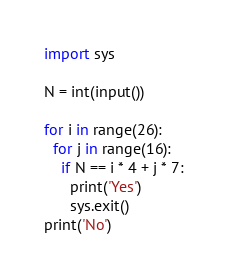<code> <loc_0><loc_0><loc_500><loc_500><_Python_>import sys
 
N = int(input())
 
for i in range(26):
  for j in range(16):
    if N == i * 4 + j * 7:
      print('Yes')
      sys.exit()
print('No')</code> 